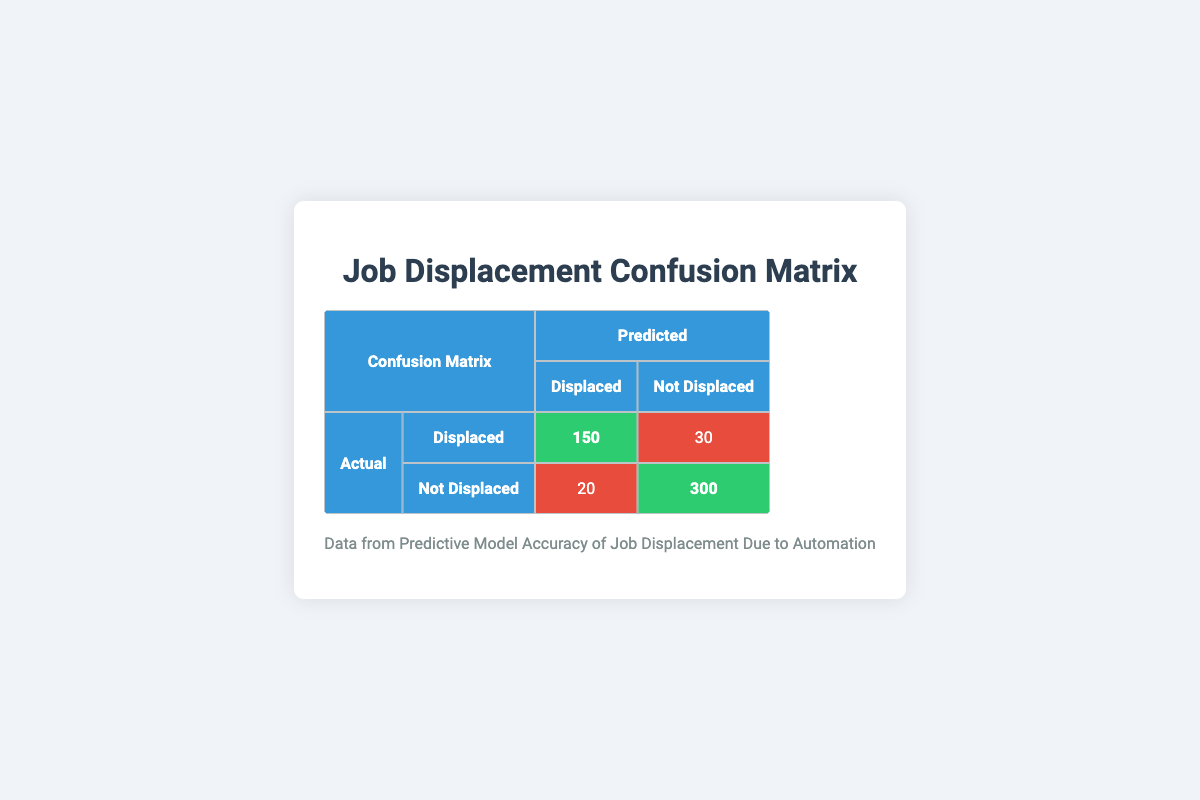What is the count of actual displaced individuals correctly predicted as displaced? According to the table, the count of actual displaced individuals that were correctly predicted as displaced is shown in the cell where "Actual" is "Displaced" and "Predicted" is "Displaced", which has a count of 150.
Answer: 150 What is the total count of individuals predicted as displaced? To find the total count predicted as displaced, we sum the counts in the "Displaced" column: 150 (actual displaced, predicted displaced) + 20 (actual not displaced, predicted displaced) = 170.
Answer: 170 How many individuals were actually not displaced but predicted as displaced? From the table, the count of individuals who were actually not displaced but were predicted as displaced is found in the cell where "Actual" is "Not Displaced" and "Predicted" is "Displaced", which is 20.
Answer: 20 Is the number of individuals correctly predicted as not displaced greater than those incorrectly predicted as not displaced? To answer this, we compare the counts: 300 (correctly predicted not displaced) vs. 30 (incorrectly predicted as not displaced). Since 300 is greater than 30, the statement is true.
Answer: Yes What is the overall prediction accuracy of the model? The overall prediction accuracy is calculated by summing all true positives (150) and true negatives (300), then dividing by the total number of predictions (150 + 30 + 20 + 300 = 500). Thus, accuracy is (150 + 300) / 500 = 450 / 500 = 0.9, which is 90%.
Answer: 90% What is the total number of individuals that were not actually displaced? The total number of individuals not actually displaced can be found by adding the counts for "Not Displaced" (both rows), which is 300 (correctly predicted) + 20 (incorrectly predicted) = 320.
Answer: 320 How many more individuals were predicted as displaced than actually displaced? To find the difference, first determine the total predicted as displaced (170) and the total actually displaced (150). The difference is 170 - 150 = 20, indicating there were 20 more predicted than actually displaced.
Answer: 20 What percentage of the actual displaced individuals were correctly predicted as displaced? To calculate the percentage, divide the number of correctly predicted displaced (150) by the total number of actual displaced individuals (150 + 30 = 180), and multiply by 100. So, (150 / 180) * 100 = 83.33%.
Answer: 83.33% 